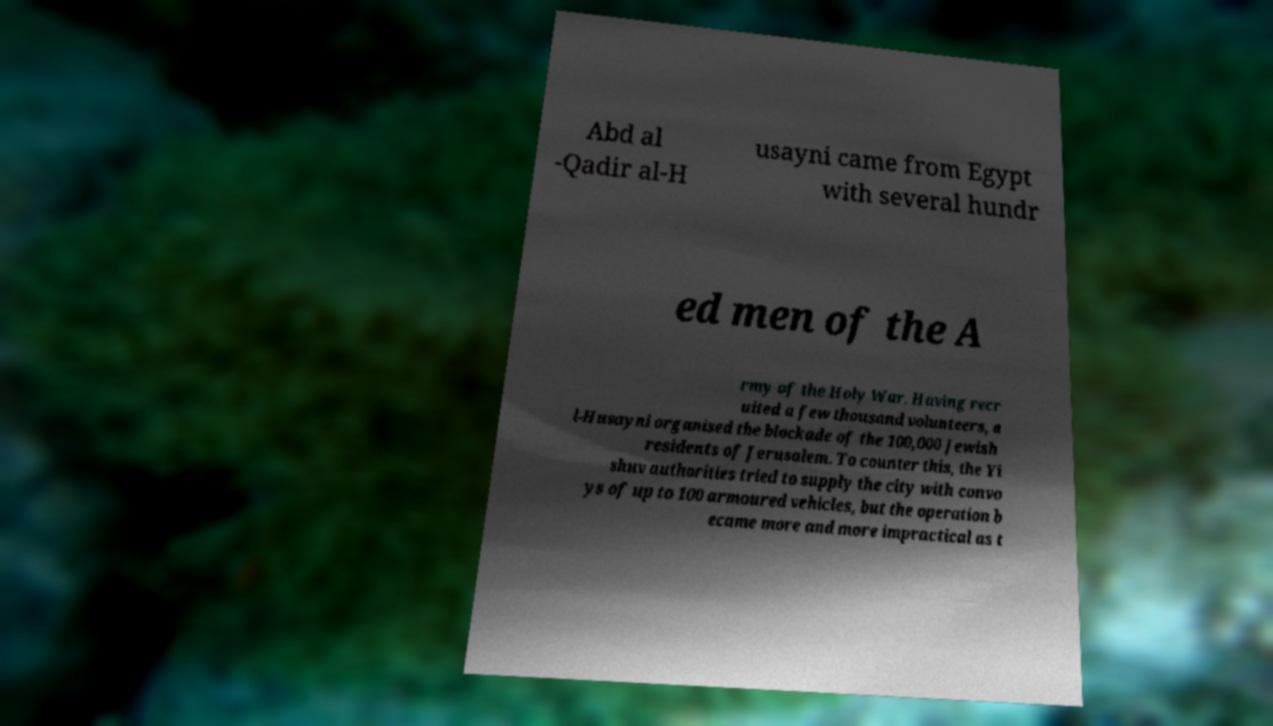Could you extract and type out the text from this image? Abd al -Qadir al-H usayni came from Egypt with several hundr ed men of the A rmy of the Holy War. Having recr uited a few thousand volunteers, a l-Husayni organised the blockade of the 100,000 Jewish residents of Jerusalem. To counter this, the Yi shuv authorities tried to supply the city with convo ys of up to 100 armoured vehicles, but the operation b ecame more and more impractical as t 